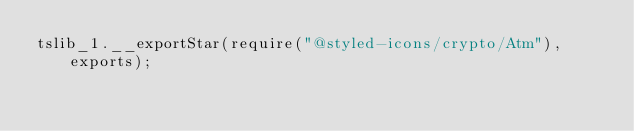Convert code to text. <code><loc_0><loc_0><loc_500><loc_500><_JavaScript_>tslib_1.__exportStar(require("@styled-icons/crypto/Atm"), exports);
</code> 